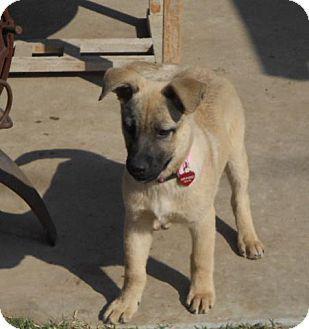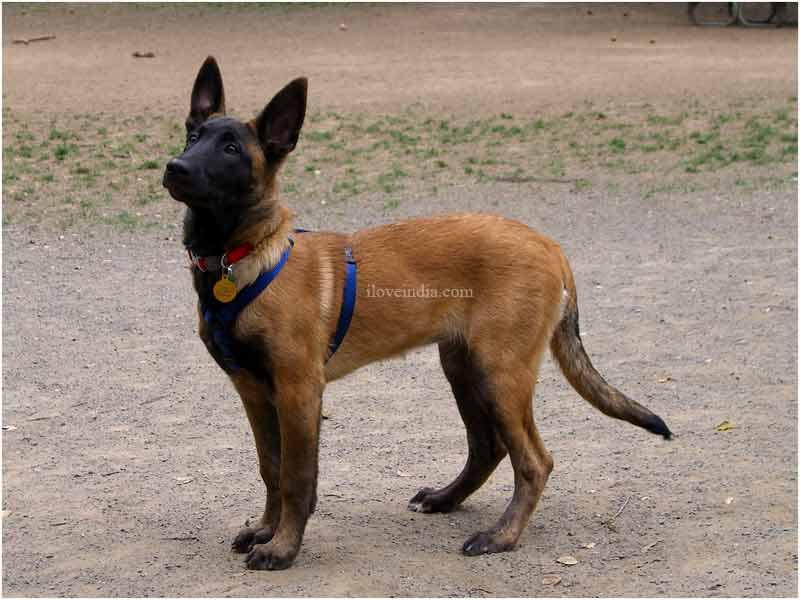The first image is the image on the left, the second image is the image on the right. For the images shown, is this caption "The dog in the image on the right is wearing a collar." true? Answer yes or no. Yes. 